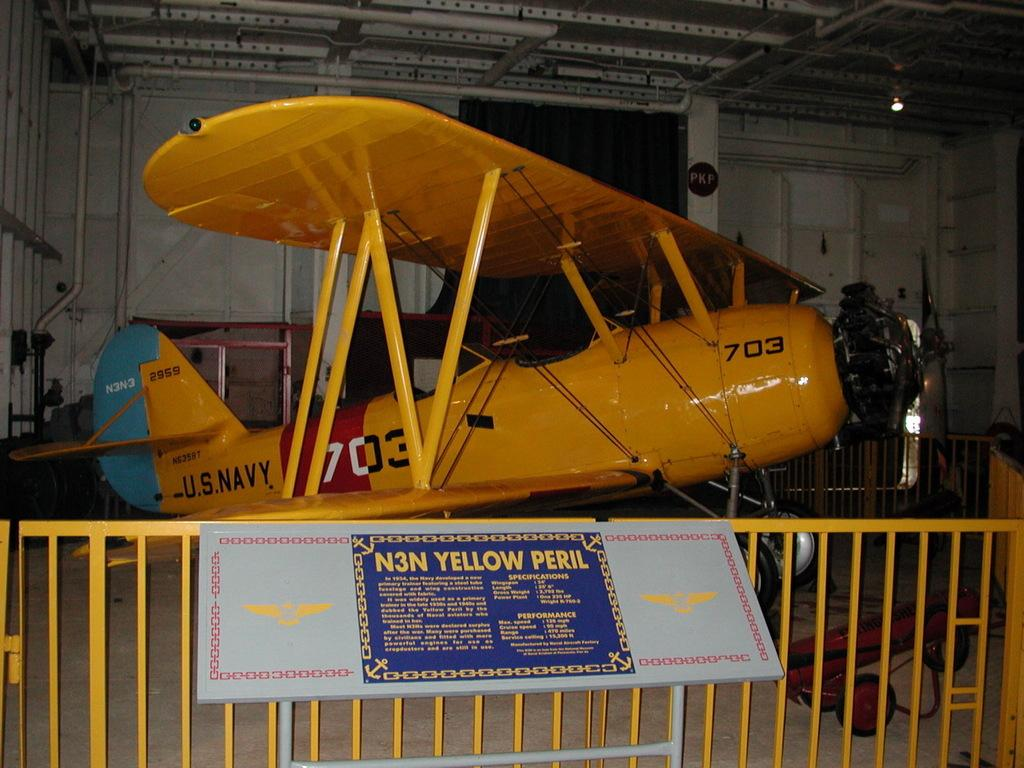<image>
Summarize the visual content of the image. A vintage Navy plane painted yellow with red and blue accents is behind a gate indoors. 